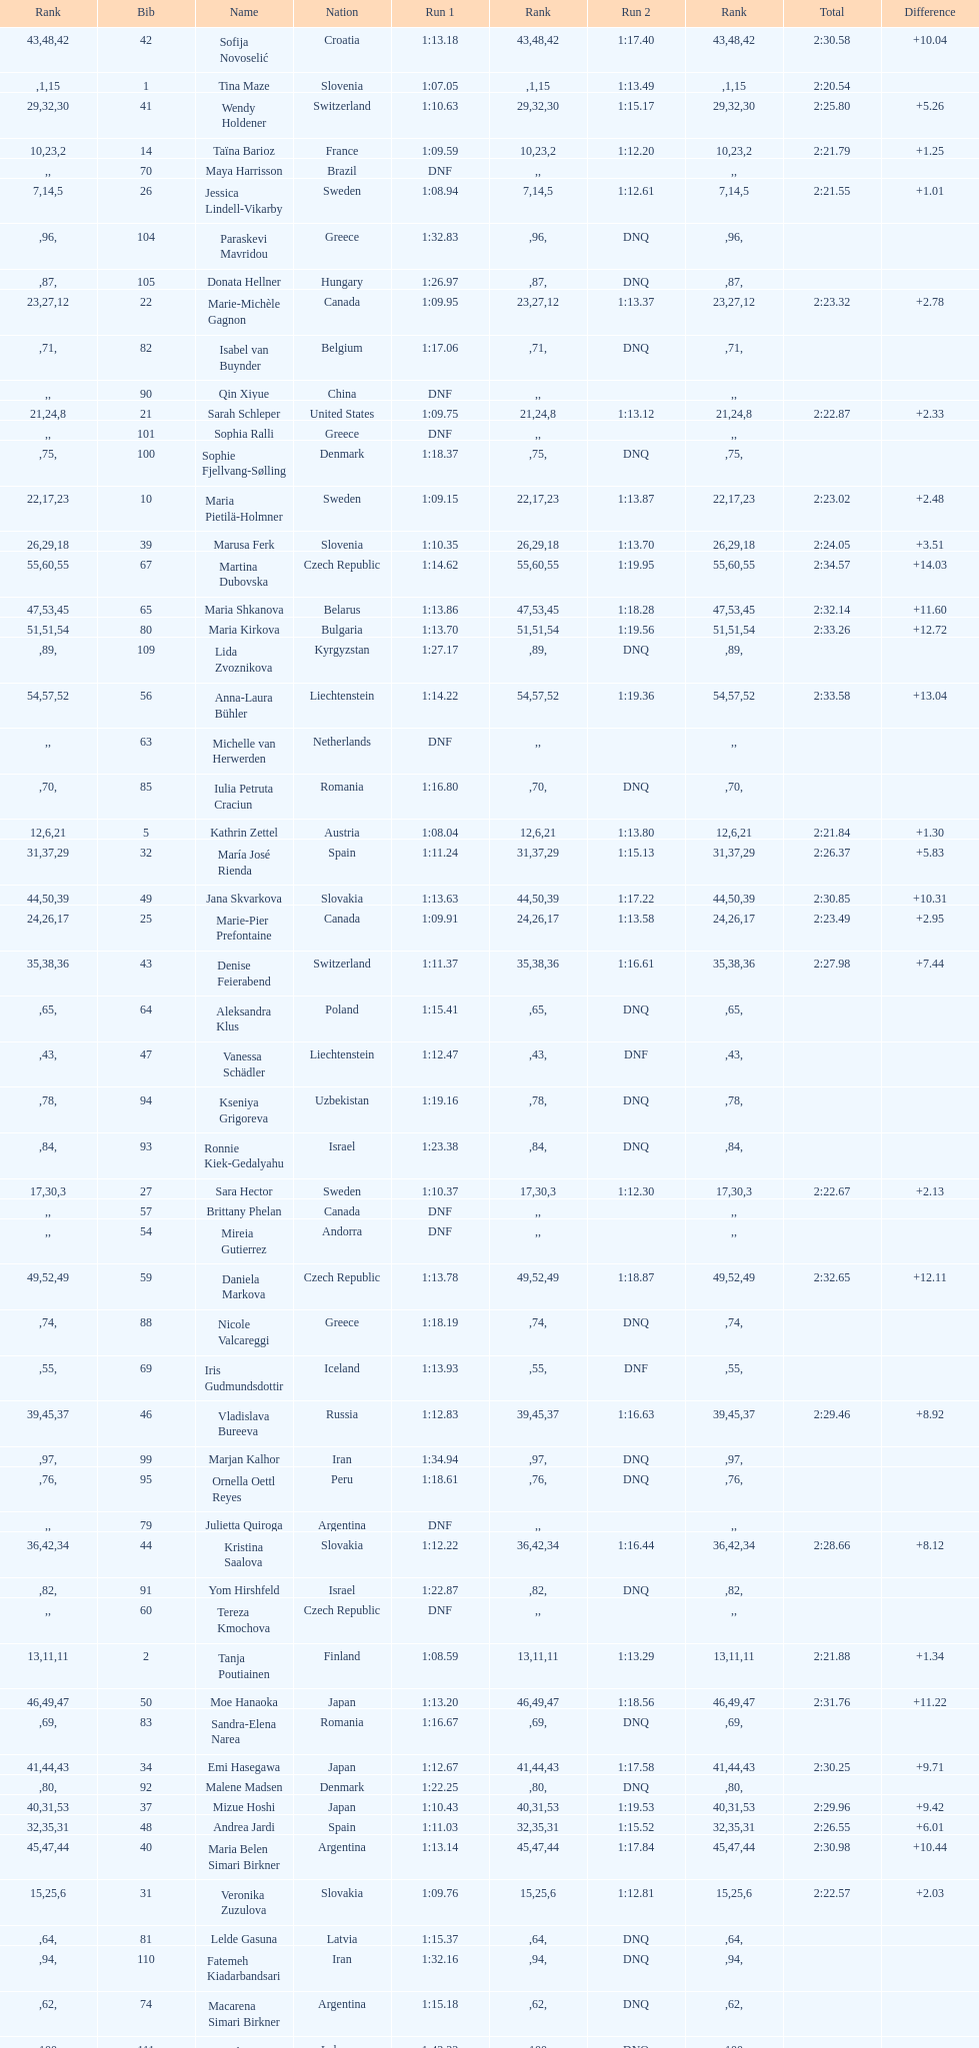What is the name before anja parson? Marlies Schild. 